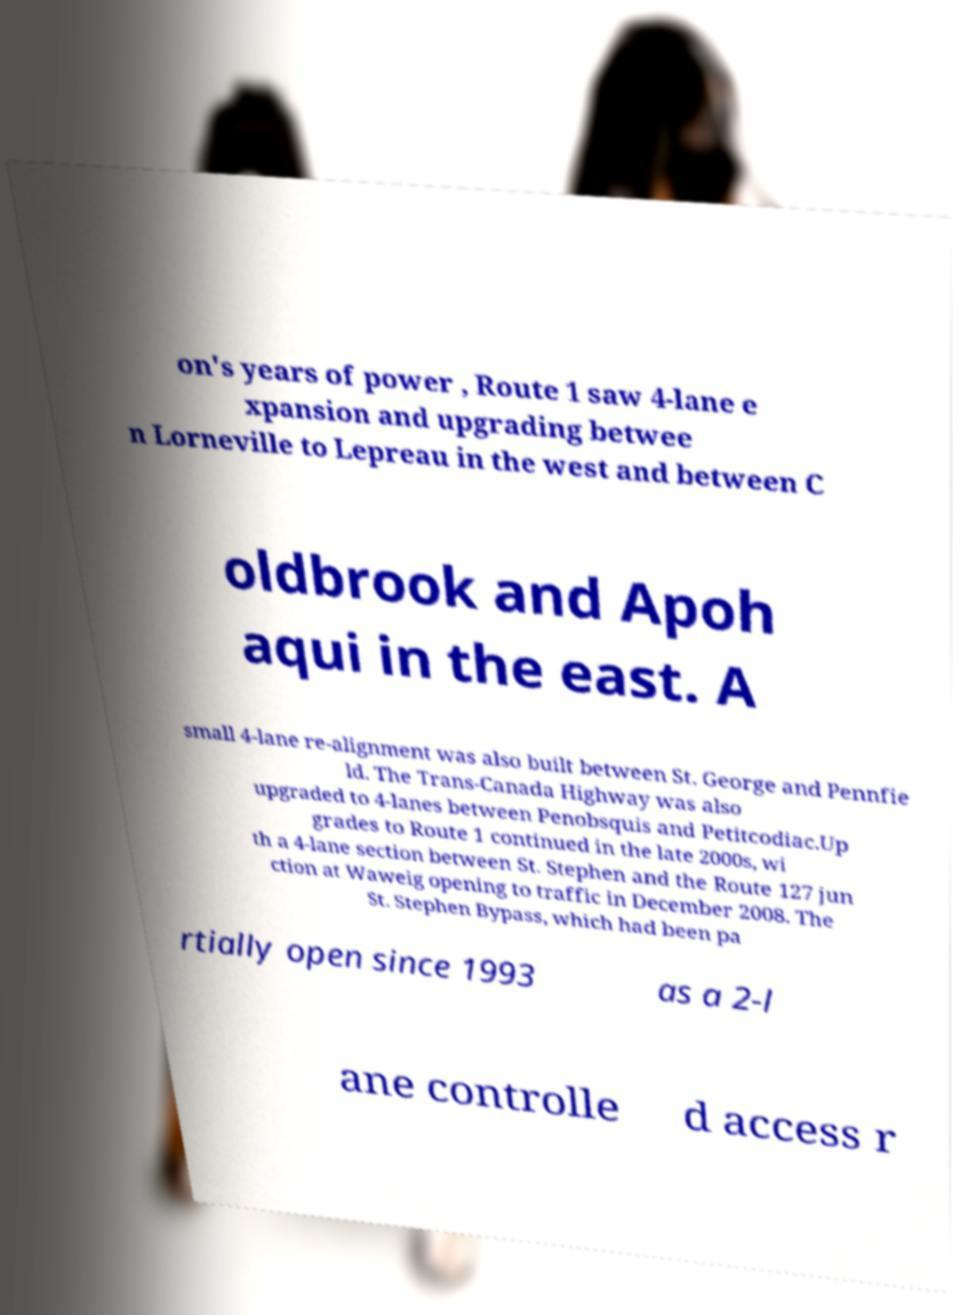There's text embedded in this image that I need extracted. Can you transcribe it verbatim? on's years of power , Route 1 saw 4-lane e xpansion and upgrading betwee n Lorneville to Lepreau in the west and between C oldbrook and Apoh aqui in the east. A small 4-lane re-alignment was also built between St. George and Pennfie ld. The Trans-Canada Highway was also upgraded to 4-lanes between Penobsquis and Petitcodiac.Up grades to Route 1 continued in the late 2000s, wi th a 4-lane section between St. Stephen and the Route 127 jun ction at Waweig opening to traffic in December 2008. The St. Stephen Bypass, which had been pa rtially open since 1993 as a 2-l ane controlle d access r 